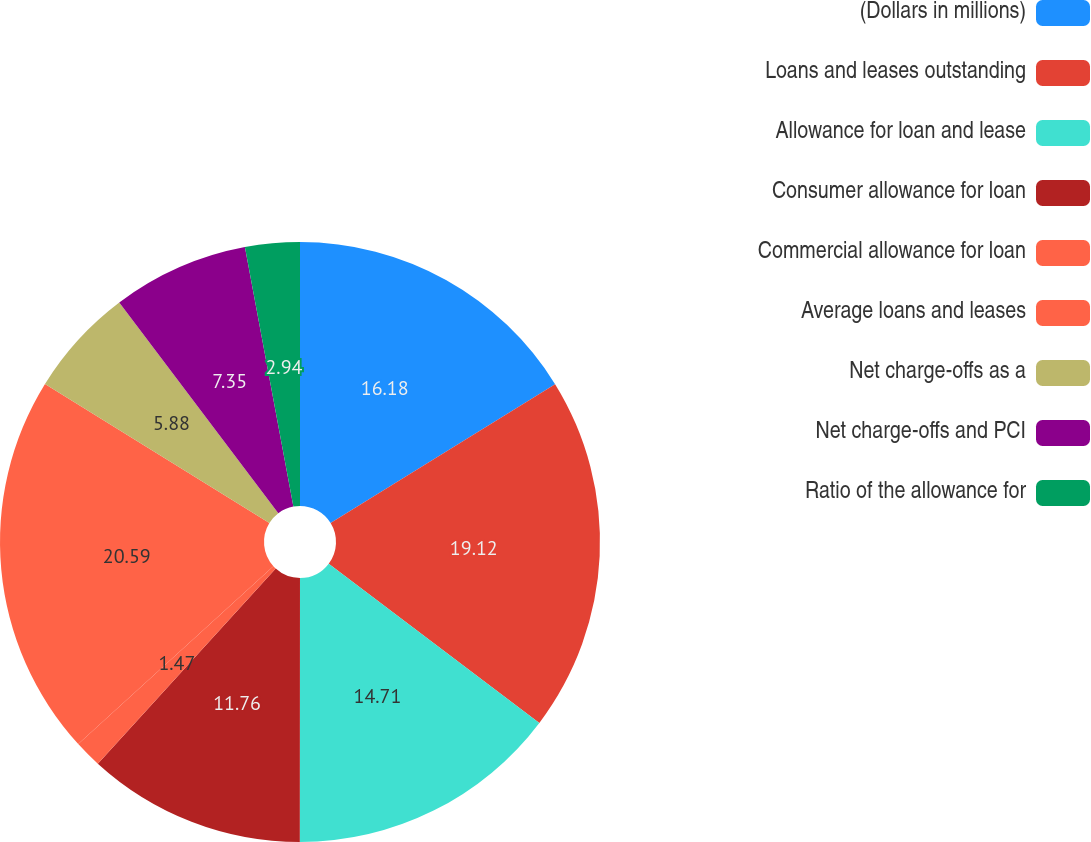Convert chart. <chart><loc_0><loc_0><loc_500><loc_500><pie_chart><fcel>(Dollars in millions)<fcel>Loans and leases outstanding<fcel>Allowance for loan and lease<fcel>Consumer allowance for loan<fcel>Commercial allowance for loan<fcel>Average loans and leases<fcel>Net charge-offs as a<fcel>Net charge-offs and PCI<fcel>Ratio of the allowance for<nl><fcel>16.18%<fcel>19.12%<fcel>14.71%<fcel>11.76%<fcel>1.47%<fcel>20.59%<fcel>5.88%<fcel>7.35%<fcel>2.94%<nl></chart> 